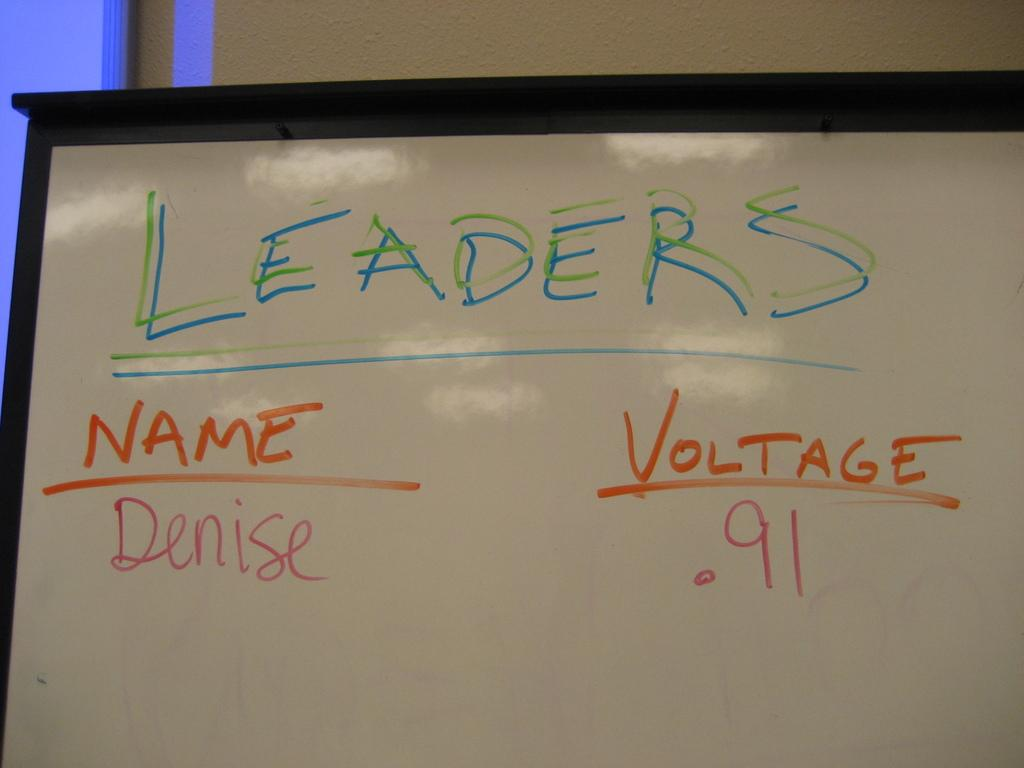<image>
Relay a brief, clear account of the picture shown. A white board with writing such as LEADERS, NAME, and VOLTAGE. 